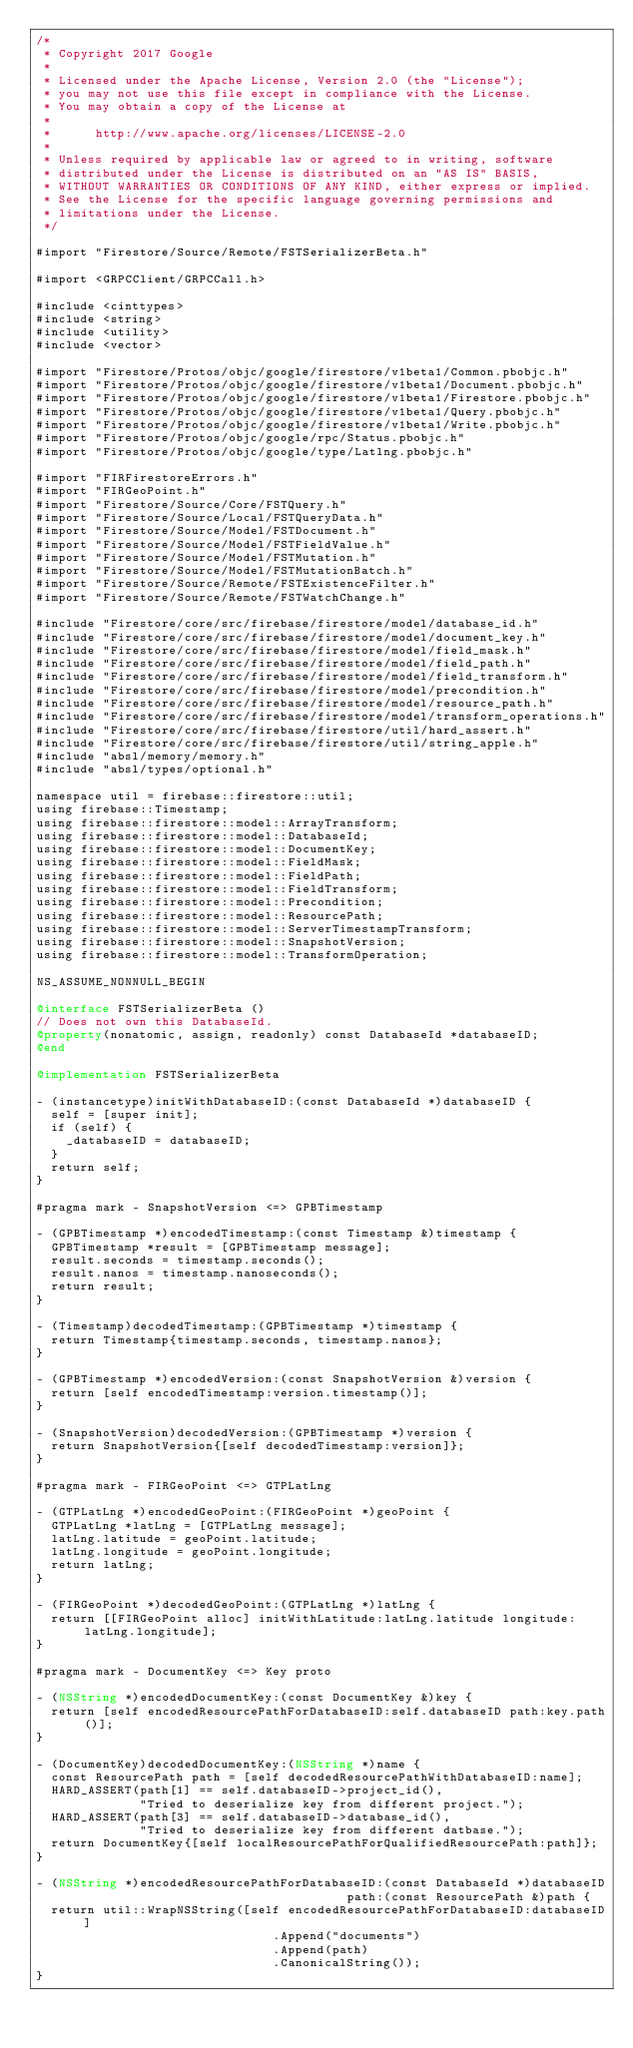Convert code to text. <code><loc_0><loc_0><loc_500><loc_500><_ObjectiveC_>/*
 * Copyright 2017 Google
 *
 * Licensed under the Apache License, Version 2.0 (the "License");
 * you may not use this file except in compliance with the License.
 * You may obtain a copy of the License at
 *
 *      http://www.apache.org/licenses/LICENSE-2.0
 *
 * Unless required by applicable law or agreed to in writing, software
 * distributed under the License is distributed on an "AS IS" BASIS,
 * WITHOUT WARRANTIES OR CONDITIONS OF ANY KIND, either express or implied.
 * See the License for the specific language governing permissions and
 * limitations under the License.
 */

#import "Firestore/Source/Remote/FSTSerializerBeta.h"

#import <GRPCClient/GRPCCall.h>

#include <cinttypes>
#include <string>
#include <utility>
#include <vector>

#import "Firestore/Protos/objc/google/firestore/v1beta1/Common.pbobjc.h"
#import "Firestore/Protos/objc/google/firestore/v1beta1/Document.pbobjc.h"
#import "Firestore/Protos/objc/google/firestore/v1beta1/Firestore.pbobjc.h"
#import "Firestore/Protos/objc/google/firestore/v1beta1/Query.pbobjc.h"
#import "Firestore/Protos/objc/google/firestore/v1beta1/Write.pbobjc.h"
#import "Firestore/Protos/objc/google/rpc/Status.pbobjc.h"
#import "Firestore/Protos/objc/google/type/Latlng.pbobjc.h"

#import "FIRFirestoreErrors.h"
#import "FIRGeoPoint.h"
#import "Firestore/Source/Core/FSTQuery.h"
#import "Firestore/Source/Local/FSTQueryData.h"
#import "Firestore/Source/Model/FSTDocument.h"
#import "Firestore/Source/Model/FSTFieldValue.h"
#import "Firestore/Source/Model/FSTMutation.h"
#import "Firestore/Source/Model/FSTMutationBatch.h"
#import "Firestore/Source/Remote/FSTExistenceFilter.h"
#import "Firestore/Source/Remote/FSTWatchChange.h"

#include "Firestore/core/src/firebase/firestore/model/database_id.h"
#include "Firestore/core/src/firebase/firestore/model/document_key.h"
#include "Firestore/core/src/firebase/firestore/model/field_mask.h"
#include "Firestore/core/src/firebase/firestore/model/field_path.h"
#include "Firestore/core/src/firebase/firestore/model/field_transform.h"
#include "Firestore/core/src/firebase/firestore/model/precondition.h"
#include "Firestore/core/src/firebase/firestore/model/resource_path.h"
#include "Firestore/core/src/firebase/firestore/model/transform_operations.h"
#include "Firestore/core/src/firebase/firestore/util/hard_assert.h"
#include "Firestore/core/src/firebase/firestore/util/string_apple.h"
#include "absl/memory/memory.h"
#include "absl/types/optional.h"

namespace util = firebase::firestore::util;
using firebase::Timestamp;
using firebase::firestore::model::ArrayTransform;
using firebase::firestore::model::DatabaseId;
using firebase::firestore::model::DocumentKey;
using firebase::firestore::model::FieldMask;
using firebase::firestore::model::FieldPath;
using firebase::firestore::model::FieldTransform;
using firebase::firestore::model::Precondition;
using firebase::firestore::model::ResourcePath;
using firebase::firestore::model::ServerTimestampTransform;
using firebase::firestore::model::SnapshotVersion;
using firebase::firestore::model::TransformOperation;

NS_ASSUME_NONNULL_BEGIN

@interface FSTSerializerBeta ()
// Does not own this DatabaseId.
@property(nonatomic, assign, readonly) const DatabaseId *databaseID;
@end

@implementation FSTSerializerBeta

- (instancetype)initWithDatabaseID:(const DatabaseId *)databaseID {
  self = [super init];
  if (self) {
    _databaseID = databaseID;
  }
  return self;
}

#pragma mark - SnapshotVersion <=> GPBTimestamp

- (GPBTimestamp *)encodedTimestamp:(const Timestamp &)timestamp {
  GPBTimestamp *result = [GPBTimestamp message];
  result.seconds = timestamp.seconds();
  result.nanos = timestamp.nanoseconds();
  return result;
}

- (Timestamp)decodedTimestamp:(GPBTimestamp *)timestamp {
  return Timestamp{timestamp.seconds, timestamp.nanos};
}

- (GPBTimestamp *)encodedVersion:(const SnapshotVersion &)version {
  return [self encodedTimestamp:version.timestamp()];
}

- (SnapshotVersion)decodedVersion:(GPBTimestamp *)version {
  return SnapshotVersion{[self decodedTimestamp:version]};
}

#pragma mark - FIRGeoPoint <=> GTPLatLng

- (GTPLatLng *)encodedGeoPoint:(FIRGeoPoint *)geoPoint {
  GTPLatLng *latLng = [GTPLatLng message];
  latLng.latitude = geoPoint.latitude;
  latLng.longitude = geoPoint.longitude;
  return latLng;
}

- (FIRGeoPoint *)decodedGeoPoint:(GTPLatLng *)latLng {
  return [[FIRGeoPoint alloc] initWithLatitude:latLng.latitude longitude:latLng.longitude];
}

#pragma mark - DocumentKey <=> Key proto

- (NSString *)encodedDocumentKey:(const DocumentKey &)key {
  return [self encodedResourcePathForDatabaseID:self.databaseID path:key.path()];
}

- (DocumentKey)decodedDocumentKey:(NSString *)name {
  const ResourcePath path = [self decodedResourcePathWithDatabaseID:name];
  HARD_ASSERT(path[1] == self.databaseID->project_id(),
              "Tried to deserialize key from different project.");
  HARD_ASSERT(path[3] == self.databaseID->database_id(),
              "Tried to deserialize key from different datbase.");
  return DocumentKey{[self localResourcePathForQualifiedResourcePath:path]};
}

- (NSString *)encodedResourcePathForDatabaseID:(const DatabaseId *)databaseID
                                          path:(const ResourcePath &)path {
  return util::WrapNSString([self encodedResourcePathForDatabaseID:databaseID]
                                .Append("documents")
                                .Append(path)
                                .CanonicalString());
}
</code> 